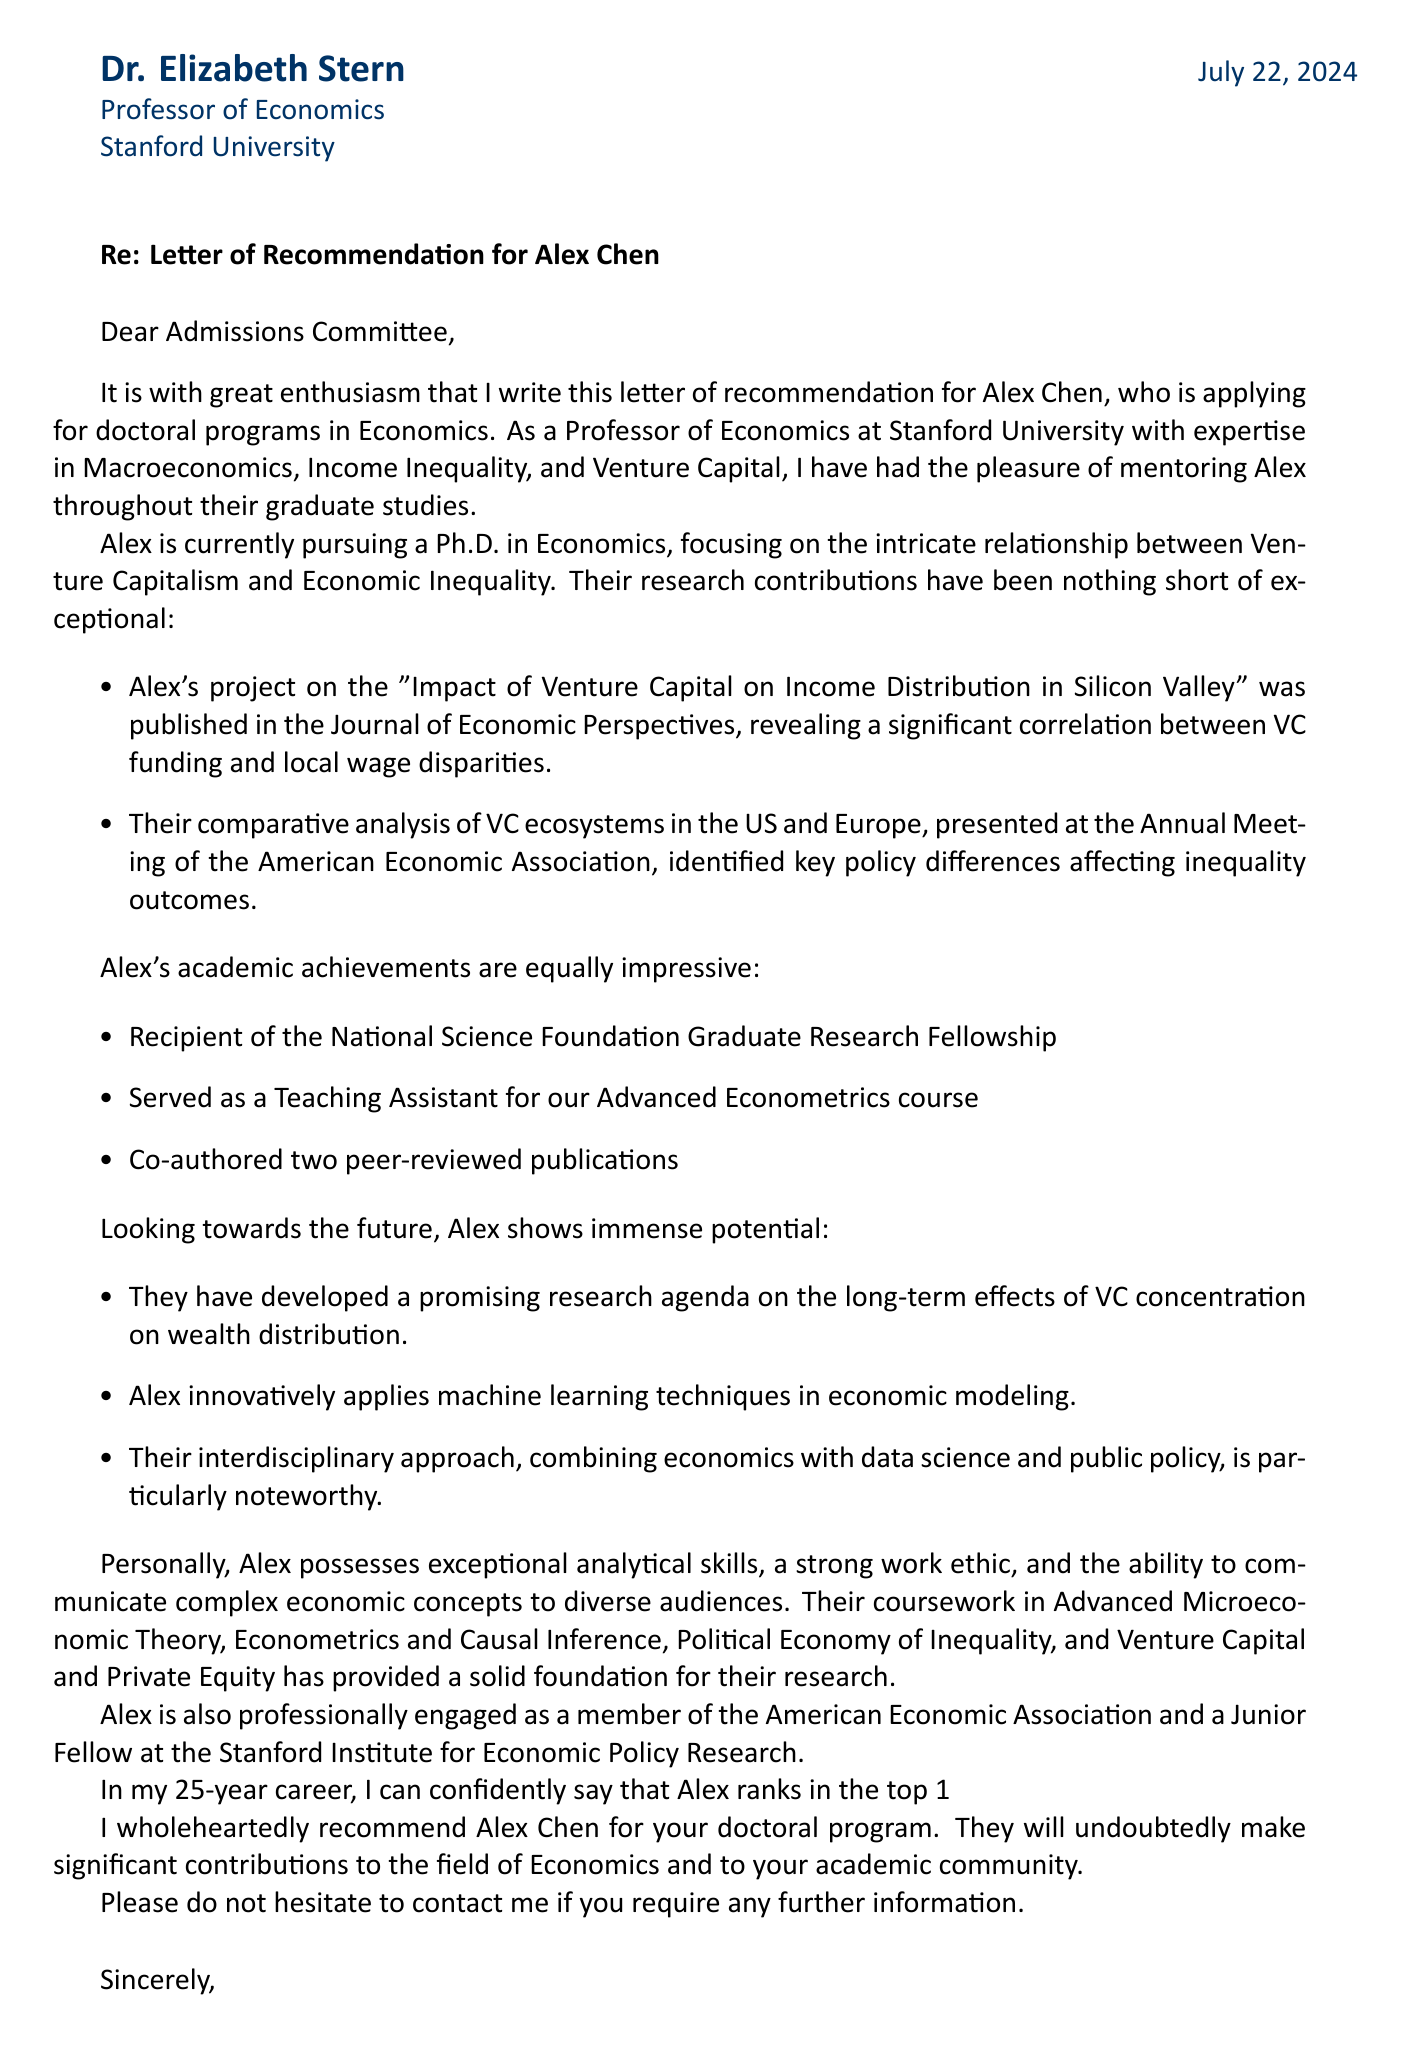What is the professor's name? The document provides the name of the professor as Dr. Elizabeth Stern.
Answer: Dr. Elizabeth Stern What is the student's research focus? The research focus of the student, Alex Chen, is on Venture Capitalism and Economic Inequality.
Answer: Venture Capitalism and Economic Inequality Which journal published the student's project on Silicon Valley? The document states that the project was published in the Journal of Economic Perspectives.
Answer: Journal of Economic Perspectives How many peer-reviewed publications has the student co-authored? The document mentions that Alex Chen has co-authored two peer-reviewed publications.
Answer: two What percentage of graduate students does the professor rank Alex Chen? The professor ranks Alex Chen in the top 1% of graduate students she has mentored.
Answer: top 1% What future research potential does Alex have? The document mentions that Alex has a promising research agenda on long-term effects of VC concentration on wealth distribution.
Answer: promising research agenda on long-term effects of VC concentration on wealth distribution Which professional association is Alex a member of? The document indicates that Alex is a member of the American Economic Association.
Answer: American Economic Association What kind of potential does the professor see in Alex? The document highlights that the professor sees potential for Alex to become a leading scholar in the field.
Answer: leading scholar in the field What is the purpose of the letter? The primary purpose of the letter is to recommend Alex Chen for doctoral programs in Economics.
Answer: recommend Alex Chen for doctoral programs in Economics 